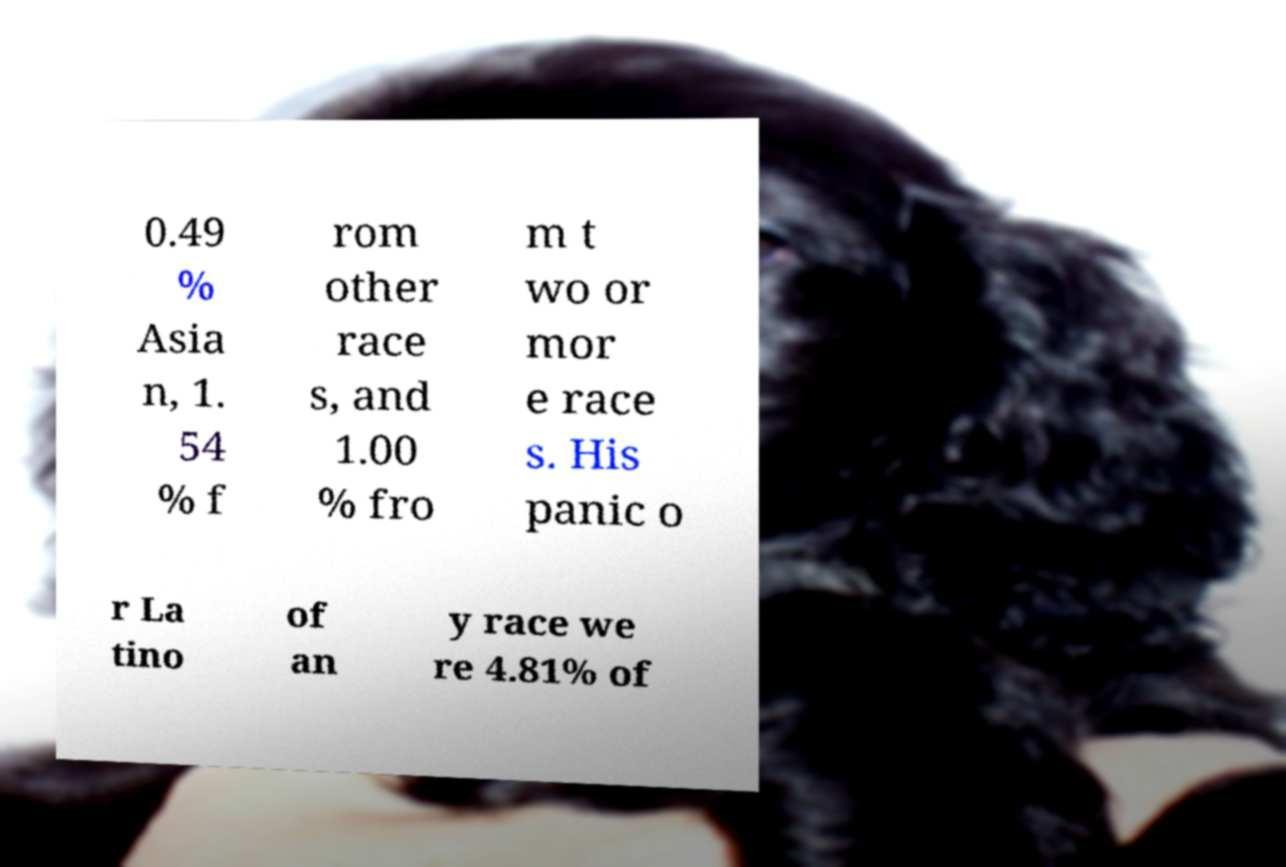Can you read and provide the text displayed in the image?This photo seems to have some interesting text. Can you extract and type it out for me? 0.49 % Asia n, 1. 54 % f rom other race s, and 1.00 % fro m t wo or mor e race s. His panic o r La tino of an y race we re 4.81% of 